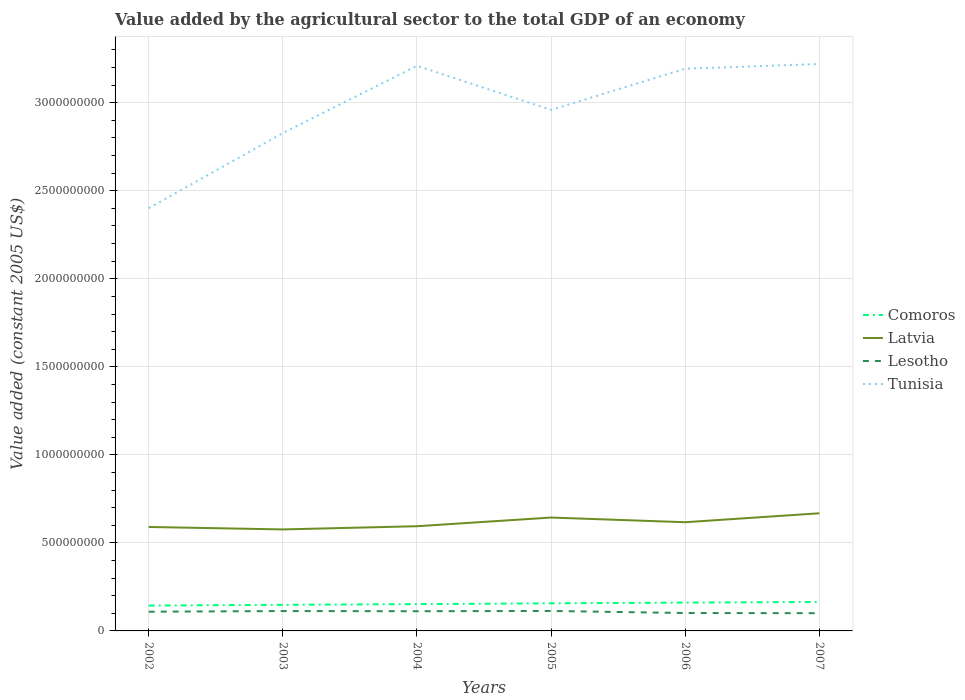How many different coloured lines are there?
Keep it short and to the point. 4. Does the line corresponding to Lesotho intersect with the line corresponding to Tunisia?
Your answer should be compact. No. Across all years, what is the maximum value added by the agricultural sector in Tunisia?
Ensure brevity in your answer.  2.40e+09. What is the total value added by the agricultural sector in Tunisia in the graph?
Your answer should be compact. -8.09e+08. What is the difference between the highest and the second highest value added by the agricultural sector in Tunisia?
Offer a very short reply. 8.19e+08. How many lines are there?
Provide a succinct answer. 4. How many years are there in the graph?
Give a very brief answer. 6. What is the difference between two consecutive major ticks on the Y-axis?
Your response must be concise. 5.00e+08. Does the graph contain any zero values?
Give a very brief answer. No. Does the graph contain grids?
Give a very brief answer. Yes. Where does the legend appear in the graph?
Your answer should be very brief. Center right. How many legend labels are there?
Make the answer very short. 4. What is the title of the graph?
Ensure brevity in your answer.  Value added by the agricultural sector to the total GDP of an economy. Does "Congo (Republic)" appear as one of the legend labels in the graph?
Your answer should be compact. No. What is the label or title of the Y-axis?
Provide a succinct answer. Value added (constant 2005 US$). What is the Value added (constant 2005 US$) in Comoros in 2002?
Give a very brief answer. 1.44e+08. What is the Value added (constant 2005 US$) of Latvia in 2002?
Your response must be concise. 5.90e+08. What is the Value added (constant 2005 US$) of Lesotho in 2002?
Your answer should be very brief. 1.09e+08. What is the Value added (constant 2005 US$) in Tunisia in 2002?
Offer a very short reply. 2.40e+09. What is the Value added (constant 2005 US$) of Comoros in 2003?
Your answer should be very brief. 1.48e+08. What is the Value added (constant 2005 US$) of Latvia in 2003?
Give a very brief answer. 5.77e+08. What is the Value added (constant 2005 US$) of Lesotho in 2003?
Provide a short and direct response. 1.13e+08. What is the Value added (constant 2005 US$) in Tunisia in 2003?
Offer a terse response. 2.83e+09. What is the Value added (constant 2005 US$) of Comoros in 2004?
Offer a very short reply. 1.52e+08. What is the Value added (constant 2005 US$) in Latvia in 2004?
Keep it short and to the point. 5.95e+08. What is the Value added (constant 2005 US$) in Lesotho in 2004?
Your answer should be very brief. 1.12e+08. What is the Value added (constant 2005 US$) of Tunisia in 2004?
Make the answer very short. 3.21e+09. What is the Value added (constant 2005 US$) in Comoros in 2005?
Provide a succinct answer. 1.57e+08. What is the Value added (constant 2005 US$) of Latvia in 2005?
Your answer should be very brief. 6.44e+08. What is the Value added (constant 2005 US$) in Lesotho in 2005?
Ensure brevity in your answer.  1.13e+08. What is the Value added (constant 2005 US$) of Tunisia in 2005?
Your answer should be compact. 2.96e+09. What is the Value added (constant 2005 US$) of Comoros in 2006?
Your response must be concise. 1.61e+08. What is the Value added (constant 2005 US$) in Latvia in 2006?
Provide a succinct answer. 6.17e+08. What is the Value added (constant 2005 US$) of Lesotho in 2006?
Provide a succinct answer. 1.02e+08. What is the Value added (constant 2005 US$) of Tunisia in 2006?
Keep it short and to the point. 3.19e+09. What is the Value added (constant 2005 US$) in Comoros in 2007?
Provide a short and direct response. 1.65e+08. What is the Value added (constant 2005 US$) of Latvia in 2007?
Give a very brief answer. 6.68e+08. What is the Value added (constant 2005 US$) of Lesotho in 2007?
Your answer should be compact. 1.01e+08. What is the Value added (constant 2005 US$) of Tunisia in 2007?
Offer a terse response. 3.22e+09. Across all years, what is the maximum Value added (constant 2005 US$) of Comoros?
Your response must be concise. 1.65e+08. Across all years, what is the maximum Value added (constant 2005 US$) in Latvia?
Your response must be concise. 6.68e+08. Across all years, what is the maximum Value added (constant 2005 US$) in Lesotho?
Offer a terse response. 1.13e+08. Across all years, what is the maximum Value added (constant 2005 US$) of Tunisia?
Your answer should be compact. 3.22e+09. Across all years, what is the minimum Value added (constant 2005 US$) in Comoros?
Ensure brevity in your answer.  1.44e+08. Across all years, what is the minimum Value added (constant 2005 US$) of Latvia?
Provide a short and direct response. 5.77e+08. Across all years, what is the minimum Value added (constant 2005 US$) in Lesotho?
Your answer should be compact. 1.01e+08. Across all years, what is the minimum Value added (constant 2005 US$) in Tunisia?
Provide a short and direct response. 2.40e+09. What is the total Value added (constant 2005 US$) of Comoros in the graph?
Ensure brevity in your answer.  9.27e+08. What is the total Value added (constant 2005 US$) in Latvia in the graph?
Make the answer very short. 3.69e+09. What is the total Value added (constant 2005 US$) in Lesotho in the graph?
Your answer should be very brief. 6.50e+08. What is the total Value added (constant 2005 US$) in Tunisia in the graph?
Give a very brief answer. 1.78e+1. What is the difference between the Value added (constant 2005 US$) in Comoros in 2002 and that in 2003?
Offer a very short reply. -4.19e+06. What is the difference between the Value added (constant 2005 US$) of Latvia in 2002 and that in 2003?
Your response must be concise. 1.39e+07. What is the difference between the Value added (constant 2005 US$) of Lesotho in 2002 and that in 2003?
Ensure brevity in your answer.  -3.74e+06. What is the difference between the Value added (constant 2005 US$) of Tunisia in 2002 and that in 2003?
Your answer should be compact. -4.27e+08. What is the difference between the Value added (constant 2005 US$) in Comoros in 2002 and that in 2004?
Provide a succinct answer. -8.19e+06. What is the difference between the Value added (constant 2005 US$) of Latvia in 2002 and that in 2004?
Give a very brief answer. -4.24e+06. What is the difference between the Value added (constant 2005 US$) in Lesotho in 2002 and that in 2004?
Offer a terse response. -2.69e+06. What is the difference between the Value added (constant 2005 US$) of Tunisia in 2002 and that in 2004?
Ensure brevity in your answer.  -8.09e+08. What is the difference between the Value added (constant 2005 US$) in Comoros in 2002 and that in 2005?
Offer a terse response. -1.28e+07. What is the difference between the Value added (constant 2005 US$) in Latvia in 2002 and that in 2005?
Offer a very short reply. -5.36e+07. What is the difference between the Value added (constant 2005 US$) in Lesotho in 2002 and that in 2005?
Provide a succinct answer. -4.26e+06. What is the difference between the Value added (constant 2005 US$) in Tunisia in 2002 and that in 2005?
Keep it short and to the point. -5.58e+08. What is the difference between the Value added (constant 2005 US$) in Comoros in 2002 and that in 2006?
Offer a terse response. -1.69e+07. What is the difference between the Value added (constant 2005 US$) of Latvia in 2002 and that in 2006?
Your answer should be very brief. -2.70e+07. What is the difference between the Value added (constant 2005 US$) of Lesotho in 2002 and that in 2006?
Offer a very short reply. 7.43e+06. What is the difference between the Value added (constant 2005 US$) of Tunisia in 2002 and that in 2006?
Keep it short and to the point. -7.92e+08. What is the difference between the Value added (constant 2005 US$) in Comoros in 2002 and that in 2007?
Make the answer very short. -2.06e+07. What is the difference between the Value added (constant 2005 US$) in Latvia in 2002 and that in 2007?
Your answer should be very brief. -7.78e+07. What is the difference between the Value added (constant 2005 US$) in Lesotho in 2002 and that in 2007?
Provide a short and direct response. 8.36e+06. What is the difference between the Value added (constant 2005 US$) of Tunisia in 2002 and that in 2007?
Your answer should be very brief. -8.19e+08. What is the difference between the Value added (constant 2005 US$) in Comoros in 2003 and that in 2004?
Give a very brief answer. -4.00e+06. What is the difference between the Value added (constant 2005 US$) of Latvia in 2003 and that in 2004?
Provide a short and direct response. -1.82e+07. What is the difference between the Value added (constant 2005 US$) in Lesotho in 2003 and that in 2004?
Make the answer very short. 1.05e+06. What is the difference between the Value added (constant 2005 US$) in Tunisia in 2003 and that in 2004?
Your answer should be very brief. -3.82e+08. What is the difference between the Value added (constant 2005 US$) of Comoros in 2003 and that in 2005?
Offer a terse response. -8.57e+06. What is the difference between the Value added (constant 2005 US$) of Latvia in 2003 and that in 2005?
Make the answer very short. -6.75e+07. What is the difference between the Value added (constant 2005 US$) of Lesotho in 2003 and that in 2005?
Give a very brief answer. -5.27e+05. What is the difference between the Value added (constant 2005 US$) in Tunisia in 2003 and that in 2005?
Offer a terse response. -1.32e+08. What is the difference between the Value added (constant 2005 US$) in Comoros in 2003 and that in 2006?
Give a very brief answer. -1.27e+07. What is the difference between the Value added (constant 2005 US$) of Latvia in 2003 and that in 2006?
Your answer should be very brief. -4.09e+07. What is the difference between the Value added (constant 2005 US$) in Lesotho in 2003 and that in 2006?
Offer a very short reply. 1.12e+07. What is the difference between the Value added (constant 2005 US$) of Tunisia in 2003 and that in 2006?
Your answer should be very brief. -3.66e+08. What is the difference between the Value added (constant 2005 US$) in Comoros in 2003 and that in 2007?
Your answer should be compact. -1.64e+07. What is the difference between the Value added (constant 2005 US$) in Latvia in 2003 and that in 2007?
Offer a terse response. -9.17e+07. What is the difference between the Value added (constant 2005 US$) of Lesotho in 2003 and that in 2007?
Ensure brevity in your answer.  1.21e+07. What is the difference between the Value added (constant 2005 US$) of Tunisia in 2003 and that in 2007?
Offer a terse response. -3.92e+08. What is the difference between the Value added (constant 2005 US$) in Comoros in 2004 and that in 2005?
Your answer should be compact. -4.57e+06. What is the difference between the Value added (constant 2005 US$) in Latvia in 2004 and that in 2005?
Ensure brevity in your answer.  -4.93e+07. What is the difference between the Value added (constant 2005 US$) in Lesotho in 2004 and that in 2005?
Your answer should be compact. -1.57e+06. What is the difference between the Value added (constant 2005 US$) of Tunisia in 2004 and that in 2005?
Give a very brief answer. 2.51e+08. What is the difference between the Value added (constant 2005 US$) in Comoros in 2004 and that in 2006?
Make the answer very short. -8.66e+06. What is the difference between the Value added (constant 2005 US$) in Latvia in 2004 and that in 2006?
Provide a succinct answer. -2.27e+07. What is the difference between the Value added (constant 2005 US$) in Lesotho in 2004 and that in 2006?
Keep it short and to the point. 1.01e+07. What is the difference between the Value added (constant 2005 US$) in Tunisia in 2004 and that in 2006?
Offer a very short reply. 1.65e+07. What is the difference between the Value added (constant 2005 US$) in Comoros in 2004 and that in 2007?
Keep it short and to the point. -1.24e+07. What is the difference between the Value added (constant 2005 US$) of Latvia in 2004 and that in 2007?
Your response must be concise. -7.35e+07. What is the difference between the Value added (constant 2005 US$) in Lesotho in 2004 and that in 2007?
Provide a succinct answer. 1.11e+07. What is the difference between the Value added (constant 2005 US$) of Tunisia in 2004 and that in 2007?
Ensure brevity in your answer.  -9.90e+06. What is the difference between the Value added (constant 2005 US$) in Comoros in 2005 and that in 2006?
Make the answer very short. -4.09e+06. What is the difference between the Value added (constant 2005 US$) of Latvia in 2005 and that in 2006?
Offer a terse response. 2.66e+07. What is the difference between the Value added (constant 2005 US$) of Lesotho in 2005 and that in 2006?
Offer a terse response. 1.17e+07. What is the difference between the Value added (constant 2005 US$) of Tunisia in 2005 and that in 2006?
Offer a terse response. -2.34e+08. What is the difference between the Value added (constant 2005 US$) of Comoros in 2005 and that in 2007?
Provide a short and direct response. -7.80e+06. What is the difference between the Value added (constant 2005 US$) in Latvia in 2005 and that in 2007?
Your answer should be very brief. -2.42e+07. What is the difference between the Value added (constant 2005 US$) of Lesotho in 2005 and that in 2007?
Offer a terse response. 1.26e+07. What is the difference between the Value added (constant 2005 US$) in Tunisia in 2005 and that in 2007?
Your response must be concise. -2.61e+08. What is the difference between the Value added (constant 2005 US$) of Comoros in 2006 and that in 2007?
Your response must be concise. -3.71e+06. What is the difference between the Value added (constant 2005 US$) in Latvia in 2006 and that in 2007?
Your answer should be very brief. -5.08e+07. What is the difference between the Value added (constant 2005 US$) in Lesotho in 2006 and that in 2007?
Your response must be concise. 9.36e+05. What is the difference between the Value added (constant 2005 US$) in Tunisia in 2006 and that in 2007?
Your answer should be very brief. -2.64e+07. What is the difference between the Value added (constant 2005 US$) in Comoros in 2002 and the Value added (constant 2005 US$) in Latvia in 2003?
Offer a very short reply. -4.32e+08. What is the difference between the Value added (constant 2005 US$) in Comoros in 2002 and the Value added (constant 2005 US$) in Lesotho in 2003?
Your response must be concise. 3.12e+07. What is the difference between the Value added (constant 2005 US$) in Comoros in 2002 and the Value added (constant 2005 US$) in Tunisia in 2003?
Give a very brief answer. -2.68e+09. What is the difference between the Value added (constant 2005 US$) of Latvia in 2002 and the Value added (constant 2005 US$) of Lesotho in 2003?
Give a very brief answer. 4.78e+08. What is the difference between the Value added (constant 2005 US$) in Latvia in 2002 and the Value added (constant 2005 US$) in Tunisia in 2003?
Make the answer very short. -2.24e+09. What is the difference between the Value added (constant 2005 US$) in Lesotho in 2002 and the Value added (constant 2005 US$) in Tunisia in 2003?
Make the answer very short. -2.72e+09. What is the difference between the Value added (constant 2005 US$) in Comoros in 2002 and the Value added (constant 2005 US$) in Latvia in 2004?
Provide a succinct answer. -4.51e+08. What is the difference between the Value added (constant 2005 US$) in Comoros in 2002 and the Value added (constant 2005 US$) in Lesotho in 2004?
Offer a terse response. 3.22e+07. What is the difference between the Value added (constant 2005 US$) of Comoros in 2002 and the Value added (constant 2005 US$) of Tunisia in 2004?
Give a very brief answer. -3.07e+09. What is the difference between the Value added (constant 2005 US$) of Latvia in 2002 and the Value added (constant 2005 US$) of Lesotho in 2004?
Provide a short and direct response. 4.79e+08. What is the difference between the Value added (constant 2005 US$) in Latvia in 2002 and the Value added (constant 2005 US$) in Tunisia in 2004?
Provide a succinct answer. -2.62e+09. What is the difference between the Value added (constant 2005 US$) in Lesotho in 2002 and the Value added (constant 2005 US$) in Tunisia in 2004?
Keep it short and to the point. -3.10e+09. What is the difference between the Value added (constant 2005 US$) in Comoros in 2002 and the Value added (constant 2005 US$) in Latvia in 2005?
Offer a terse response. -5.00e+08. What is the difference between the Value added (constant 2005 US$) of Comoros in 2002 and the Value added (constant 2005 US$) of Lesotho in 2005?
Offer a terse response. 3.07e+07. What is the difference between the Value added (constant 2005 US$) in Comoros in 2002 and the Value added (constant 2005 US$) in Tunisia in 2005?
Make the answer very short. -2.82e+09. What is the difference between the Value added (constant 2005 US$) of Latvia in 2002 and the Value added (constant 2005 US$) of Lesotho in 2005?
Your answer should be compact. 4.77e+08. What is the difference between the Value added (constant 2005 US$) of Latvia in 2002 and the Value added (constant 2005 US$) of Tunisia in 2005?
Provide a short and direct response. -2.37e+09. What is the difference between the Value added (constant 2005 US$) in Lesotho in 2002 and the Value added (constant 2005 US$) in Tunisia in 2005?
Your answer should be compact. -2.85e+09. What is the difference between the Value added (constant 2005 US$) in Comoros in 2002 and the Value added (constant 2005 US$) in Latvia in 2006?
Your response must be concise. -4.73e+08. What is the difference between the Value added (constant 2005 US$) in Comoros in 2002 and the Value added (constant 2005 US$) in Lesotho in 2006?
Make the answer very short. 4.24e+07. What is the difference between the Value added (constant 2005 US$) in Comoros in 2002 and the Value added (constant 2005 US$) in Tunisia in 2006?
Ensure brevity in your answer.  -3.05e+09. What is the difference between the Value added (constant 2005 US$) in Latvia in 2002 and the Value added (constant 2005 US$) in Lesotho in 2006?
Provide a short and direct response. 4.89e+08. What is the difference between the Value added (constant 2005 US$) of Latvia in 2002 and the Value added (constant 2005 US$) of Tunisia in 2006?
Ensure brevity in your answer.  -2.60e+09. What is the difference between the Value added (constant 2005 US$) of Lesotho in 2002 and the Value added (constant 2005 US$) of Tunisia in 2006?
Ensure brevity in your answer.  -3.08e+09. What is the difference between the Value added (constant 2005 US$) of Comoros in 2002 and the Value added (constant 2005 US$) of Latvia in 2007?
Offer a terse response. -5.24e+08. What is the difference between the Value added (constant 2005 US$) of Comoros in 2002 and the Value added (constant 2005 US$) of Lesotho in 2007?
Provide a short and direct response. 4.33e+07. What is the difference between the Value added (constant 2005 US$) of Comoros in 2002 and the Value added (constant 2005 US$) of Tunisia in 2007?
Make the answer very short. -3.08e+09. What is the difference between the Value added (constant 2005 US$) of Latvia in 2002 and the Value added (constant 2005 US$) of Lesotho in 2007?
Your answer should be compact. 4.90e+08. What is the difference between the Value added (constant 2005 US$) in Latvia in 2002 and the Value added (constant 2005 US$) in Tunisia in 2007?
Provide a short and direct response. -2.63e+09. What is the difference between the Value added (constant 2005 US$) in Lesotho in 2002 and the Value added (constant 2005 US$) in Tunisia in 2007?
Offer a terse response. -3.11e+09. What is the difference between the Value added (constant 2005 US$) of Comoros in 2003 and the Value added (constant 2005 US$) of Latvia in 2004?
Your answer should be compact. -4.46e+08. What is the difference between the Value added (constant 2005 US$) of Comoros in 2003 and the Value added (constant 2005 US$) of Lesotho in 2004?
Provide a short and direct response. 3.64e+07. What is the difference between the Value added (constant 2005 US$) of Comoros in 2003 and the Value added (constant 2005 US$) of Tunisia in 2004?
Offer a very short reply. -3.06e+09. What is the difference between the Value added (constant 2005 US$) of Latvia in 2003 and the Value added (constant 2005 US$) of Lesotho in 2004?
Give a very brief answer. 4.65e+08. What is the difference between the Value added (constant 2005 US$) of Latvia in 2003 and the Value added (constant 2005 US$) of Tunisia in 2004?
Provide a short and direct response. -2.63e+09. What is the difference between the Value added (constant 2005 US$) of Lesotho in 2003 and the Value added (constant 2005 US$) of Tunisia in 2004?
Ensure brevity in your answer.  -3.10e+09. What is the difference between the Value added (constant 2005 US$) in Comoros in 2003 and the Value added (constant 2005 US$) in Latvia in 2005?
Your response must be concise. -4.96e+08. What is the difference between the Value added (constant 2005 US$) of Comoros in 2003 and the Value added (constant 2005 US$) of Lesotho in 2005?
Your answer should be very brief. 3.49e+07. What is the difference between the Value added (constant 2005 US$) of Comoros in 2003 and the Value added (constant 2005 US$) of Tunisia in 2005?
Keep it short and to the point. -2.81e+09. What is the difference between the Value added (constant 2005 US$) of Latvia in 2003 and the Value added (constant 2005 US$) of Lesotho in 2005?
Your answer should be compact. 4.63e+08. What is the difference between the Value added (constant 2005 US$) of Latvia in 2003 and the Value added (constant 2005 US$) of Tunisia in 2005?
Give a very brief answer. -2.38e+09. What is the difference between the Value added (constant 2005 US$) of Lesotho in 2003 and the Value added (constant 2005 US$) of Tunisia in 2005?
Your answer should be very brief. -2.85e+09. What is the difference between the Value added (constant 2005 US$) of Comoros in 2003 and the Value added (constant 2005 US$) of Latvia in 2006?
Provide a succinct answer. -4.69e+08. What is the difference between the Value added (constant 2005 US$) of Comoros in 2003 and the Value added (constant 2005 US$) of Lesotho in 2006?
Keep it short and to the point. 4.65e+07. What is the difference between the Value added (constant 2005 US$) in Comoros in 2003 and the Value added (constant 2005 US$) in Tunisia in 2006?
Make the answer very short. -3.05e+09. What is the difference between the Value added (constant 2005 US$) in Latvia in 2003 and the Value added (constant 2005 US$) in Lesotho in 2006?
Provide a short and direct response. 4.75e+08. What is the difference between the Value added (constant 2005 US$) in Latvia in 2003 and the Value added (constant 2005 US$) in Tunisia in 2006?
Your answer should be very brief. -2.62e+09. What is the difference between the Value added (constant 2005 US$) of Lesotho in 2003 and the Value added (constant 2005 US$) of Tunisia in 2006?
Give a very brief answer. -3.08e+09. What is the difference between the Value added (constant 2005 US$) of Comoros in 2003 and the Value added (constant 2005 US$) of Latvia in 2007?
Make the answer very short. -5.20e+08. What is the difference between the Value added (constant 2005 US$) in Comoros in 2003 and the Value added (constant 2005 US$) in Lesotho in 2007?
Offer a very short reply. 4.75e+07. What is the difference between the Value added (constant 2005 US$) of Comoros in 2003 and the Value added (constant 2005 US$) of Tunisia in 2007?
Offer a terse response. -3.07e+09. What is the difference between the Value added (constant 2005 US$) of Latvia in 2003 and the Value added (constant 2005 US$) of Lesotho in 2007?
Your response must be concise. 4.76e+08. What is the difference between the Value added (constant 2005 US$) in Latvia in 2003 and the Value added (constant 2005 US$) in Tunisia in 2007?
Your response must be concise. -2.64e+09. What is the difference between the Value added (constant 2005 US$) in Lesotho in 2003 and the Value added (constant 2005 US$) in Tunisia in 2007?
Give a very brief answer. -3.11e+09. What is the difference between the Value added (constant 2005 US$) of Comoros in 2004 and the Value added (constant 2005 US$) of Latvia in 2005?
Your answer should be very brief. -4.92e+08. What is the difference between the Value added (constant 2005 US$) in Comoros in 2004 and the Value added (constant 2005 US$) in Lesotho in 2005?
Your answer should be very brief. 3.89e+07. What is the difference between the Value added (constant 2005 US$) in Comoros in 2004 and the Value added (constant 2005 US$) in Tunisia in 2005?
Your answer should be very brief. -2.81e+09. What is the difference between the Value added (constant 2005 US$) of Latvia in 2004 and the Value added (constant 2005 US$) of Lesotho in 2005?
Keep it short and to the point. 4.81e+08. What is the difference between the Value added (constant 2005 US$) in Latvia in 2004 and the Value added (constant 2005 US$) in Tunisia in 2005?
Provide a succinct answer. -2.36e+09. What is the difference between the Value added (constant 2005 US$) of Lesotho in 2004 and the Value added (constant 2005 US$) of Tunisia in 2005?
Provide a succinct answer. -2.85e+09. What is the difference between the Value added (constant 2005 US$) in Comoros in 2004 and the Value added (constant 2005 US$) in Latvia in 2006?
Make the answer very short. -4.65e+08. What is the difference between the Value added (constant 2005 US$) of Comoros in 2004 and the Value added (constant 2005 US$) of Lesotho in 2006?
Offer a very short reply. 5.06e+07. What is the difference between the Value added (constant 2005 US$) of Comoros in 2004 and the Value added (constant 2005 US$) of Tunisia in 2006?
Provide a succinct answer. -3.04e+09. What is the difference between the Value added (constant 2005 US$) in Latvia in 2004 and the Value added (constant 2005 US$) in Lesotho in 2006?
Ensure brevity in your answer.  4.93e+08. What is the difference between the Value added (constant 2005 US$) of Latvia in 2004 and the Value added (constant 2005 US$) of Tunisia in 2006?
Ensure brevity in your answer.  -2.60e+09. What is the difference between the Value added (constant 2005 US$) of Lesotho in 2004 and the Value added (constant 2005 US$) of Tunisia in 2006?
Provide a succinct answer. -3.08e+09. What is the difference between the Value added (constant 2005 US$) in Comoros in 2004 and the Value added (constant 2005 US$) in Latvia in 2007?
Provide a short and direct response. -5.16e+08. What is the difference between the Value added (constant 2005 US$) in Comoros in 2004 and the Value added (constant 2005 US$) in Lesotho in 2007?
Offer a terse response. 5.15e+07. What is the difference between the Value added (constant 2005 US$) of Comoros in 2004 and the Value added (constant 2005 US$) of Tunisia in 2007?
Your answer should be compact. -3.07e+09. What is the difference between the Value added (constant 2005 US$) of Latvia in 2004 and the Value added (constant 2005 US$) of Lesotho in 2007?
Your answer should be very brief. 4.94e+08. What is the difference between the Value added (constant 2005 US$) of Latvia in 2004 and the Value added (constant 2005 US$) of Tunisia in 2007?
Provide a short and direct response. -2.63e+09. What is the difference between the Value added (constant 2005 US$) of Lesotho in 2004 and the Value added (constant 2005 US$) of Tunisia in 2007?
Offer a very short reply. -3.11e+09. What is the difference between the Value added (constant 2005 US$) in Comoros in 2005 and the Value added (constant 2005 US$) in Latvia in 2006?
Your answer should be compact. -4.61e+08. What is the difference between the Value added (constant 2005 US$) of Comoros in 2005 and the Value added (constant 2005 US$) of Lesotho in 2006?
Give a very brief answer. 5.51e+07. What is the difference between the Value added (constant 2005 US$) of Comoros in 2005 and the Value added (constant 2005 US$) of Tunisia in 2006?
Make the answer very short. -3.04e+09. What is the difference between the Value added (constant 2005 US$) in Latvia in 2005 and the Value added (constant 2005 US$) in Lesotho in 2006?
Offer a terse response. 5.42e+08. What is the difference between the Value added (constant 2005 US$) of Latvia in 2005 and the Value added (constant 2005 US$) of Tunisia in 2006?
Make the answer very short. -2.55e+09. What is the difference between the Value added (constant 2005 US$) in Lesotho in 2005 and the Value added (constant 2005 US$) in Tunisia in 2006?
Keep it short and to the point. -3.08e+09. What is the difference between the Value added (constant 2005 US$) of Comoros in 2005 and the Value added (constant 2005 US$) of Latvia in 2007?
Offer a very short reply. -5.11e+08. What is the difference between the Value added (constant 2005 US$) in Comoros in 2005 and the Value added (constant 2005 US$) in Lesotho in 2007?
Your answer should be very brief. 5.61e+07. What is the difference between the Value added (constant 2005 US$) in Comoros in 2005 and the Value added (constant 2005 US$) in Tunisia in 2007?
Keep it short and to the point. -3.06e+09. What is the difference between the Value added (constant 2005 US$) of Latvia in 2005 and the Value added (constant 2005 US$) of Lesotho in 2007?
Offer a very short reply. 5.43e+08. What is the difference between the Value added (constant 2005 US$) in Latvia in 2005 and the Value added (constant 2005 US$) in Tunisia in 2007?
Provide a succinct answer. -2.58e+09. What is the difference between the Value added (constant 2005 US$) in Lesotho in 2005 and the Value added (constant 2005 US$) in Tunisia in 2007?
Your response must be concise. -3.11e+09. What is the difference between the Value added (constant 2005 US$) in Comoros in 2006 and the Value added (constant 2005 US$) in Latvia in 2007?
Offer a very short reply. -5.07e+08. What is the difference between the Value added (constant 2005 US$) of Comoros in 2006 and the Value added (constant 2005 US$) of Lesotho in 2007?
Ensure brevity in your answer.  6.01e+07. What is the difference between the Value added (constant 2005 US$) of Comoros in 2006 and the Value added (constant 2005 US$) of Tunisia in 2007?
Ensure brevity in your answer.  -3.06e+09. What is the difference between the Value added (constant 2005 US$) in Latvia in 2006 and the Value added (constant 2005 US$) in Lesotho in 2007?
Keep it short and to the point. 5.17e+08. What is the difference between the Value added (constant 2005 US$) of Latvia in 2006 and the Value added (constant 2005 US$) of Tunisia in 2007?
Your response must be concise. -2.60e+09. What is the difference between the Value added (constant 2005 US$) in Lesotho in 2006 and the Value added (constant 2005 US$) in Tunisia in 2007?
Ensure brevity in your answer.  -3.12e+09. What is the average Value added (constant 2005 US$) in Comoros per year?
Provide a succinct answer. 1.54e+08. What is the average Value added (constant 2005 US$) in Latvia per year?
Ensure brevity in your answer.  6.15e+08. What is the average Value added (constant 2005 US$) of Lesotho per year?
Your response must be concise. 1.08e+08. What is the average Value added (constant 2005 US$) in Tunisia per year?
Keep it short and to the point. 2.97e+09. In the year 2002, what is the difference between the Value added (constant 2005 US$) in Comoros and Value added (constant 2005 US$) in Latvia?
Ensure brevity in your answer.  -4.46e+08. In the year 2002, what is the difference between the Value added (constant 2005 US$) of Comoros and Value added (constant 2005 US$) of Lesotho?
Ensure brevity in your answer.  3.49e+07. In the year 2002, what is the difference between the Value added (constant 2005 US$) of Comoros and Value added (constant 2005 US$) of Tunisia?
Your answer should be compact. -2.26e+09. In the year 2002, what is the difference between the Value added (constant 2005 US$) in Latvia and Value added (constant 2005 US$) in Lesotho?
Your answer should be very brief. 4.81e+08. In the year 2002, what is the difference between the Value added (constant 2005 US$) in Latvia and Value added (constant 2005 US$) in Tunisia?
Keep it short and to the point. -1.81e+09. In the year 2002, what is the difference between the Value added (constant 2005 US$) in Lesotho and Value added (constant 2005 US$) in Tunisia?
Ensure brevity in your answer.  -2.29e+09. In the year 2003, what is the difference between the Value added (constant 2005 US$) in Comoros and Value added (constant 2005 US$) in Latvia?
Your response must be concise. -4.28e+08. In the year 2003, what is the difference between the Value added (constant 2005 US$) in Comoros and Value added (constant 2005 US$) in Lesotho?
Offer a terse response. 3.54e+07. In the year 2003, what is the difference between the Value added (constant 2005 US$) in Comoros and Value added (constant 2005 US$) in Tunisia?
Your answer should be compact. -2.68e+09. In the year 2003, what is the difference between the Value added (constant 2005 US$) in Latvia and Value added (constant 2005 US$) in Lesotho?
Give a very brief answer. 4.64e+08. In the year 2003, what is the difference between the Value added (constant 2005 US$) of Latvia and Value added (constant 2005 US$) of Tunisia?
Provide a short and direct response. -2.25e+09. In the year 2003, what is the difference between the Value added (constant 2005 US$) of Lesotho and Value added (constant 2005 US$) of Tunisia?
Make the answer very short. -2.72e+09. In the year 2004, what is the difference between the Value added (constant 2005 US$) of Comoros and Value added (constant 2005 US$) of Latvia?
Provide a short and direct response. -4.42e+08. In the year 2004, what is the difference between the Value added (constant 2005 US$) in Comoros and Value added (constant 2005 US$) in Lesotho?
Provide a succinct answer. 4.04e+07. In the year 2004, what is the difference between the Value added (constant 2005 US$) in Comoros and Value added (constant 2005 US$) in Tunisia?
Give a very brief answer. -3.06e+09. In the year 2004, what is the difference between the Value added (constant 2005 US$) of Latvia and Value added (constant 2005 US$) of Lesotho?
Keep it short and to the point. 4.83e+08. In the year 2004, what is the difference between the Value added (constant 2005 US$) of Latvia and Value added (constant 2005 US$) of Tunisia?
Your answer should be compact. -2.62e+09. In the year 2004, what is the difference between the Value added (constant 2005 US$) of Lesotho and Value added (constant 2005 US$) of Tunisia?
Offer a very short reply. -3.10e+09. In the year 2005, what is the difference between the Value added (constant 2005 US$) of Comoros and Value added (constant 2005 US$) of Latvia?
Your answer should be compact. -4.87e+08. In the year 2005, what is the difference between the Value added (constant 2005 US$) in Comoros and Value added (constant 2005 US$) in Lesotho?
Make the answer very short. 4.34e+07. In the year 2005, what is the difference between the Value added (constant 2005 US$) of Comoros and Value added (constant 2005 US$) of Tunisia?
Ensure brevity in your answer.  -2.80e+09. In the year 2005, what is the difference between the Value added (constant 2005 US$) of Latvia and Value added (constant 2005 US$) of Lesotho?
Give a very brief answer. 5.31e+08. In the year 2005, what is the difference between the Value added (constant 2005 US$) of Latvia and Value added (constant 2005 US$) of Tunisia?
Keep it short and to the point. -2.32e+09. In the year 2005, what is the difference between the Value added (constant 2005 US$) in Lesotho and Value added (constant 2005 US$) in Tunisia?
Your answer should be very brief. -2.85e+09. In the year 2006, what is the difference between the Value added (constant 2005 US$) in Comoros and Value added (constant 2005 US$) in Latvia?
Offer a terse response. -4.57e+08. In the year 2006, what is the difference between the Value added (constant 2005 US$) of Comoros and Value added (constant 2005 US$) of Lesotho?
Offer a terse response. 5.92e+07. In the year 2006, what is the difference between the Value added (constant 2005 US$) of Comoros and Value added (constant 2005 US$) of Tunisia?
Give a very brief answer. -3.03e+09. In the year 2006, what is the difference between the Value added (constant 2005 US$) in Latvia and Value added (constant 2005 US$) in Lesotho?
Offer a very short reply. 5.16e+08. In the year 2006, what is the difference between the Value added (constant 2005 US$) in Latvia and Value added (constant 2005 US$) in Tunisia?
Ensure brevity in your answer.  -2.58e+09. In the year 2006, what is the difference between the Value added (constant 2005 US$) in Lesotho and Value added (constant 2005 US$) in Tunisia?
Your answer should be very brief. -3.09e+09. In the year 2007, what is the difference between the Value added (constant 2005 US$) of Comoros and Value added (constant 2005 US$) of Latvia?
Make the answer very short. -5.04e+08. In the year 2007, what is the difference between the Value added (constant 2005 US$) in Comoros and Value added (constant 2005 US$) in Lesotho?
Offer a very short reply. 6.39e+07. In the year 2007, what is the difference between the Value added (constant 2005 US$) of Comoros and Value added (constant 2005 US$) of Tunisia?
Offer a terse response. -3.06e+09. In the year 2007, what is the difference between the Value added (constant 2005 US$) in Latvia and Value added (constant 2005 US$) in Lesotho?
Your response must be concise. 5.67e+08. In the year 2007, what is the difference between the Value added (constant 2005 US$) in Latvia and Value added (constant 2005 US$) in Tunisia?
Give a very brief answer. -2.55e+09. In the year 2007, what is the difference between the Value added (constant 2005 US$) of Lesotho and Value added (constant 2005 US$) of Tunisia?
Your answer should be compact. -3.12e+09. What is the ratio of the Value added (constant 2005 US$) in Comoros in 2002 to that in 2003?
Provide a succinct answer. 0.97. What is the ratio of the Value added (constant 2005 US$) in Latvia in 2002 to that in 2003?
Keep it short and to the point. 1.02. What is the ratio of the Value added (constant 2005 US$) of Lesotho in 2002 to that in 2003?
Offer a very short reply. 0.97. What is the ratio of the Value added (constant 2005 US$) in Tunisia in 2002 to that in 2003?
Make the answer very short. 0.85. What is the ratio of the Value added (constant 2005 US$) in Comoros in 2002 to that in 2004?
Offer a very short reply. 0.95. What is the ratio of the Value added (constant 2005 US$) of Latvia in 2002 to that in 2004?
Offer a terse response. 0.99. What is the ratio of the Value added (constant 2005 US$) in Lesotho in 2002 to that in 2004?
Keep it short and to the point. 0.98. What is the ratio of the Value added (constant 2005 US$) of Tunisia in 2002 to that in 2004?
Give a very brief answer. 0.75. What is the ratio of the Value added (constant 2005 US$) of Comoros in 2002 to that in 2005?
Ensure brevity in your answer.  0.92. What is the ratio of the Value added (constant 2005 US$) of Latvia in 2002 to that in 2005?
Ensure brevity in your answer.  0.92. What is the ratio of the Value added (constant 2005 US$) of Lesotho in 2002 to that in 2005?
Provide a short and direct response. 0.96. What is the ratio of the Value added (constant 2005 US$) in Tunisia in 2002 to that in 2005?
Your response must be concise. 0.81. What is the ratio of the Value added (constant 2005 US$) of Comoros in 2002 to that in 2006?
Offer a very short reply. 0.9. What is the ratio of the Value added (constant 2005 US$) in Latvia in 2002 to that in 2006?
Make the answer very short. 0.96. What is the ratio of the Value added (constant 2005 US$) in Lesotho in 2002 to that in 2006?
Your answer should be very brief. 1.07. What is the ratio of the Value added (constant 2005 US$) of Tunisia in 2002 to that in 2006?
Provide a succinct answer. 0.75. What is the ratio of the Value added (constant 2005 US$) of Comoros in 2002 to that in 2007?
Provide a short and direct response. 0.88. What is the ratio of the Value added (constant 2005 US$) of Latvia in 2002 to that in 2007?
Your response must be concise. 0.88. What is the ratio of the Value added (constant 2005 US$) of Lesotho in 2002 to that in 2007?
Offer a very short reply. 1.08. What is the ratio of the Value added (constant 2005 US$) of Tunisia in 2002 to that in 2007?
Provide a short and direct response. 0.75. What is the ratio of the Value added (constant 2005 US$) in Comoros in 2003 to that in 2004?
Keep it short and to the point. 0.97. What is the ratio of the Value added (constant 2005 US$) in Latvia in 2003 to that in 2004?
Your response must be concise. 0.97. What is the ratio of the Value added (constant 2005 US$) in Lesotho in 2003 to that in 2004?
Your answer should be very brief. 1.01. What is the ratio of the Value added (constant 2005 US$) of Tunisia in 2003 to that in 2004?
Offer a terse response. 0.88. What is the ratio of the Value added (constant 2005 US$) in Comoros in 2003 to that in 2005?
Your response must be concise. 0.95. What is the ratio of the Value added (constant 2005 US$) of Latvia in 2003 to that in 2005?
Make the answer very short. 0.9. What is the ratio of the Value added (constant 2005 US$) of Lesotho in 2003 to that in 2005?
Provide a short and direct response. 1. What is the ratio of the Value added (constant 2005 US$) in Tunisia in 2003 to that in 2005?
Provide a short and direct response. 0.96. What is the ratio of the Value added (constant 2005 US$) of Comoros in 2003 to that in 2006?
Offer a terse response. 0.92. What is the ratio of the Value added (constant 2005 US$) in Latvia in 2003 to that in 2006?
Provide a short and direct response. 0.93. What is the ratio of the Value added (constant 2005 US$) in Lesotho in 2003 to that in 2006?
Your response must be concise. 1.11. What is the ratio of the Value added (constant 2005 US$) of Tunisia in 2003 to that in 2006?
Your answer should be very brief. 0.89. What is the ratio of the Value added (constant 2005 US$) in Comoros in 2003 to that in 2007?
Your response must be concise. 0.9. What is the ratio of the Value added (constant 2005 US$) in Latvia in 2003 to that in 2007?
Your response must be concise. 0.86. What is the ratio of the Value added (constant 2005 US$) of Lesotho in 2003 to that in 2007?
Ensure brevity in your answer.  1.12. What is the ratio of the Value added (constant 2005 US$) of Tunisia in 2003 to that in 2007?
Ensure brevity in your answer.  0.88. What is the ratio of the Value added (constant 2005 US$) in Comoros in 2004 to that in 2005?
Ensure brevity in your answer.  0.97. What is the ratio of the Value added (constant 2005 US$) in Latvia in 2004 to that in 2005?
Make the answer very short. 0.92. What is the ratio of the Value added (constant 2005 US$) of Lesotho in 2004 to that in 2005?
Offer a very short reply. 0.99. What is the ratio of the Value added (constant 2005 US$) of Tunisia in 2004 to that in 2005?
Give a very brief answer. 1.08. What is the ratio of the Value added (constant 2005 US$) of Comoros in 2004 to that in 2006?
Provide a succinct answer. 0.95. What is the ratio of the Value added (constant 2005 US$) of Latvia in 2004 to that in 2006?
Your answer should be very brief. 0.96. What is the ratio of the Value added (constant 2005 US$) of Lesotho in 2004 to that in 2006?
Provide a succinct answer. 1.1. What is the ratio of the Value added (constant 2005 US$) of Comoros in 2004 to that in 2007?
Offer a terse response. 0.92. What is the ratio of the Value added (constant 2005 US$) of Latvia in 2004 to that in 2007?
Provide a succinct answer. 0.89. What is the ratio of the Value added (constant 2005 US$) of Lesotho in 2004 to that in 2007?
Provide a succinct answer. 1.11. What is the ratio of the Value added (constant 2005 US$) of Tunisia in 2004 to that in 2007?
Give a very brief answer. 1. What is the ratio of the Value added (constant 2005 US$) in Comoros in 2005 to that in 2006?
Keep it short and to the point. 0.97. What is the ratio of the Value added (constant 2005 US$) in Latvia in 2005 to that in 2006?
Your response must be concise. 1.04. What is the ratio of the Value added (constant 2005 US$) of Lesotho in 2005 to that in 2006?
Offer a terse response. 1.11. What is the ratio of the Value added (constant 2005 US$) in Tunisia in 2005 to that in 2006?
Make the answer very short. 0.93. What is the ratio of the Value added (constant 2005 US$) of Comoros in 2005 to that in 2007?
Make the answer very short. 0.95. What is the ratio of the Value added (constant 2005 US$) in Latvia in 2005 to that in 2007?
Your answer should be very brief. 0.96. What is the ratio of the Value added (constant 2005 US$) of Lesotho in 2005 to that in 2007?
Keep it short and to the point. 1.13. What is the ratio of the Value added (constant 2005 US$) of Tunisia in 2005 to that in 2007?
Your answer should be very brief. 0.92. What is the ratio of the Value added (constant 2005 US$) in Comoros in 2006 to that in 2007?
Your answer should be very brief. 0.98. What is the ratio of the Value added (constant 2005 US$) in Latvia in 2006 to that in 2007?
Keep it short and to the point. 0.92. What is the ratio of the Value added (constant 2005 US$) of Lesotho in 2006 to that in 2007?
Provide a succinct answer. 1.01. What is the difference between the highest and the second highest Value added (constant 2005 US$) of Comoros?
Make the answer very short. 3.71e+06. What is the difference between the highest and the second highest Value added (constant 2005 US$) in Latvia?
Your answer should be compact. 2.42e+07. What is the difference between the highest and the second highest Value added (constant 2005 US$) of Lesotho?
Ensure brevity in your answer.  5.27e+05. What is the difference between the highest and the second highest Value added (constant 2005 US$) in Tunisia?
Your response must be concise. 9.90e+06. What is the difference between the highest and the lowest Value added (constant 2005 US$) of Comoros?
Provide a succinct answer. 2.06e+07. What is the difference between the highest and the lowest Value added (constant 2005 US$) in Latvia?
Provide a short and direct response. 9.17e+07. What is the difference between the highest and the lowest Value added (constant 2005 US$) in Lesotho?
Provide a short and direct response. 1.26e+07. What is the difference between the highest and the lowest Value added (constant 2005 US$) of Tunisia?
Keep it short and to the point. 8.19e+08. 